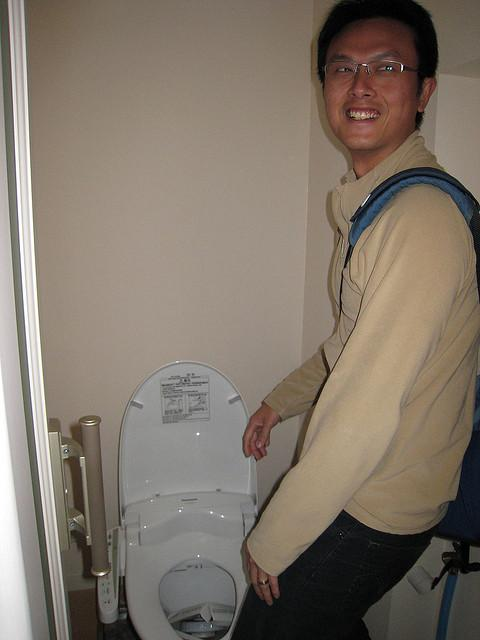What is the man ready to do next?

Choices:
A) flush
B) throw
C) rinse
D) burn flush 